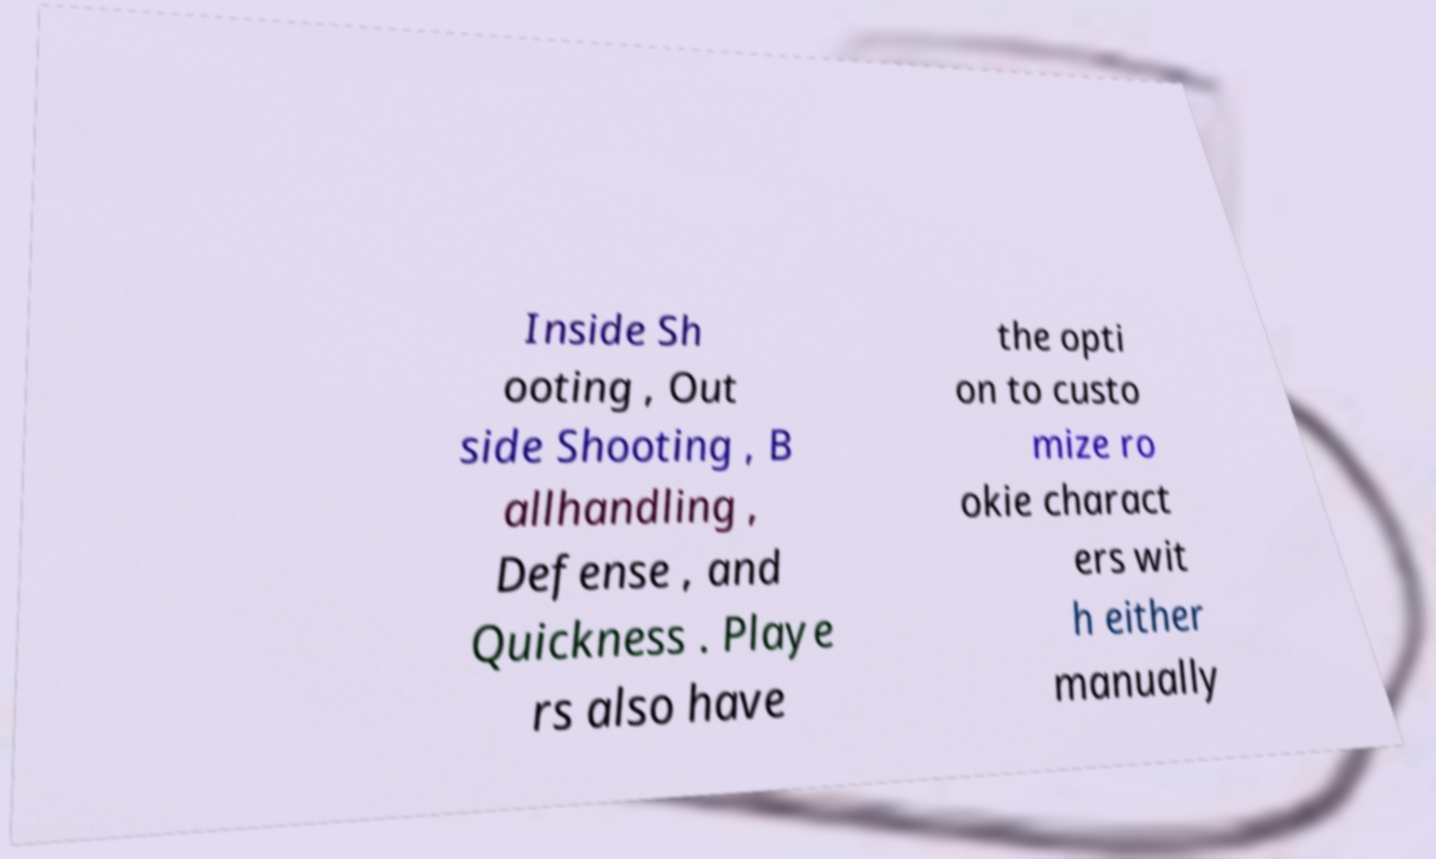Please read and relay the text visible in this image. What does it say? Inside Sh ooting , Out side Shooting , B allhandling , Defense , and Quickness . Playe rs also have the opti on to custo mize ro okie charact ers wit h either manually 